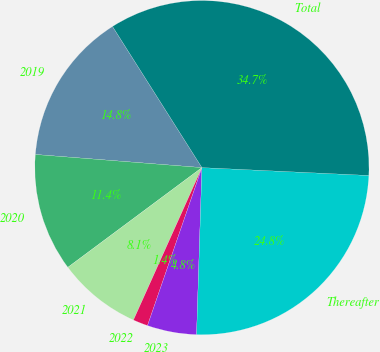Convert chart to OTSL. <chart><loc_0><loc_0><loc_500><loc_500><pie_chart><fcel>2019<fcel>2020<fcel>2021<fcel>2022<fcel>2023<fcel>Thereafter<fcel>Total<nl><fcel>14.76%<fcel>11.43%<fcel>8.1%<fcel>1.44%<fcel>4.77%<fcel>24.76%<fcel>34.73%<nl></chart> 